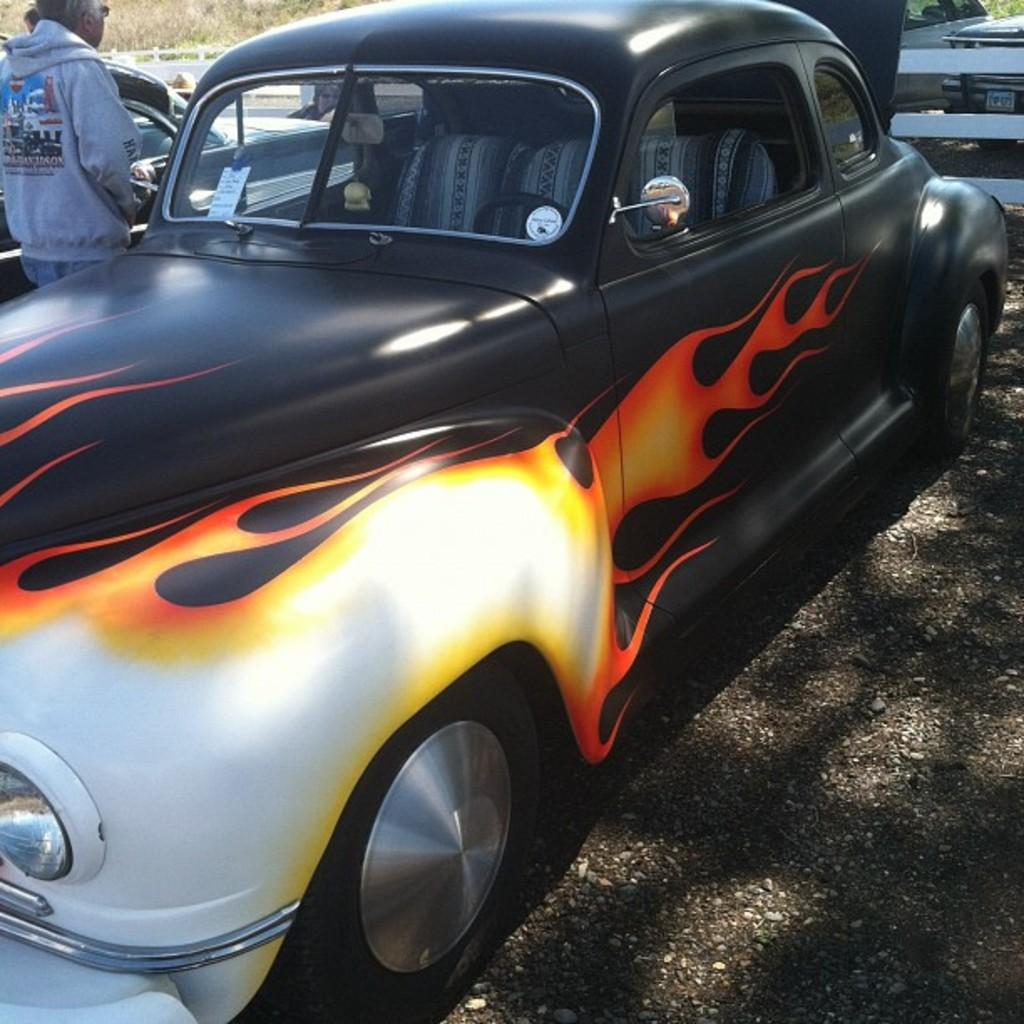What type of vehicles can be seen in the image? There are cars in the image. What is the primary setting in which the cars are located? There is a road in the image. What type of barrier is present in the image? There is fencing in the image. Can you identify any human presence in the image? Yes, there is a person in the image. What type of rail can be seen in the image? There is no rail present in the image. What type of cream is being used by the person in the image? There is no cream visible in the image, nor is there any indication that the person is using cream. 